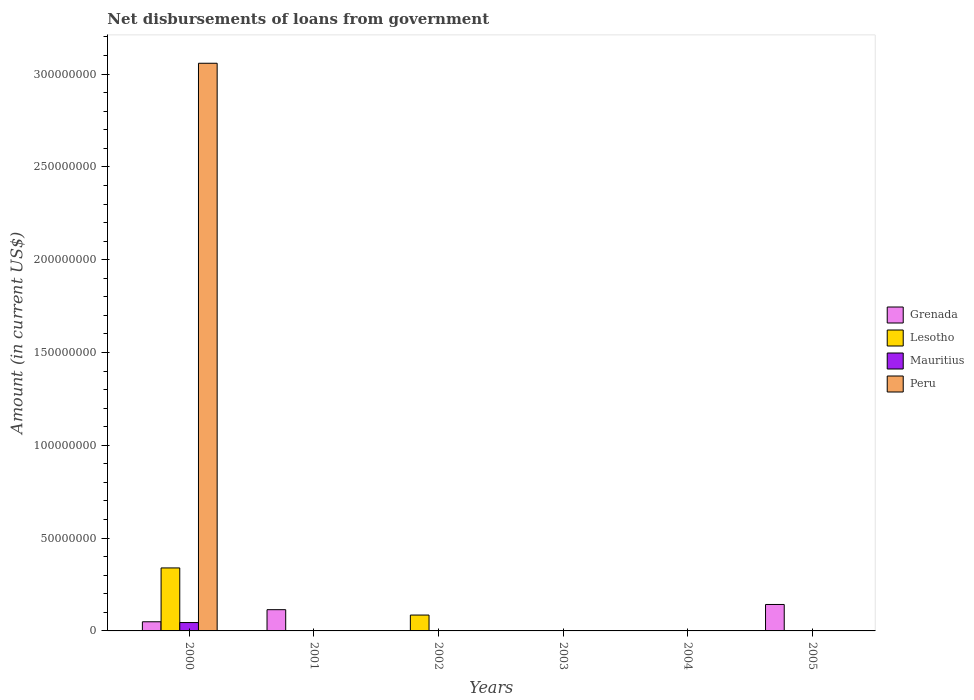How many different coloured bars are there?
Offer a very short reply. 4. How many bars are there on the 1st tick from the left?
Make the answer very short. 4. What is the label of the 4th group of bars from the left?
Ensure brevity in your answer.  2003. In how many cases, is the number of bars for a given year not equal to the number of legend labels?
Your answer should be very brief. 5. What is the amount of loan disbursed from government in Peru in 2000?
Ensure brevity in your answer.  3.06e+08. Across all years, what is the maximum amount of loan disbursed from government in Grenada?
Your answer should be compact. 1.42e+07. Across all years, what is the minimum amount of loan disbursed from government in Mauritius?
Make the answer very short. 0. In which year was the amount of loan disbursed from government in Lesotho maximum?
Ensure brevity in your answer.  2000. What is the total amount of loan disbursed from government in Lesotho in the graph?
Your answer should be very brief. 4.25e+07. What is the difference between the amount of loan disbursed from government in Grenada in 2000 and that in 2001?
Your answer should be very brief. -6.52e+06. What is the difference between the amount of loan disbursed from government in Peru in 2003 and the amount of loan disbursed from government in Grenada in 2005?
Your response must be concise. -1.42e+07. What is the average amount of loan disbursed from government in Peru per year?
Offer a terse response. 5.10e+07. In the year 2000, what is the difference between the amount of loan disbursed from government in Grenada and amount of loan disbursed from government in Mauritius?
Keep it short and to the point. 4.19e+05. What is the difference between the highest and the second highest amount of loan disbursed from government in Grenada?
Your answer should be compact. 2.80e+06. What is the difference between the highest and the lowest amount of loan disbursed from government in Lesotho?
Make the answer very short. 3.39e+07. How many bars are there?
Your response must be concise. 7. Are all the bars in the graph horizontal?
Keep it short and to the point. No. How many years are there in the graph?
Your answer should be compact. 6. What is the difference between two consecutive major ticks on the Y-axis?
Provide a short and direct response. 5.00e+07. How are the legend labels stacked?
Offer a very short reply. Vertical. What is the title of the graph?
Make the answer very short. Net disbursements of loans from government. Does "Aruba" appear as one of the legend labels in the graph?
Offer a very short reply. No. What is the label or title of the X-axis?
Your answer should be very brief. Years. What is the Amount (in current US$) of Grenada in 2000?
Your answer should be compact. 4.93e+06. What is the Amount (in current US$) in Lesotho in 2000?
Offer a terse response. 3.39e+07. What is the Amount (in current US$) of Mauritius in 2000?
Your answer should be very brief. 4.51e+06. What is the Amount (in current US$) of Peru in 2000?
Ensure brevity in your answer.  3.06e+08. What is the Amount (in current US$) of Grenada in 2001?
Your answer should be compact. 1.14e+07. What is the Amount (in current US$) in Peru in 2001?
Give a very brief answer. 0. What is the Amount (in current US$) of Grenada in 2002?
Provide a short and direct response. 0. What is the Amount (in current US$) in Lesotho in 2002?
Make the answer very short. 8.55e+06. What is the Amount (in current US$) of Peru in 2002?
Your response must be concise. 0. What is the Amount (in current US$) in Lesotho in 2003?
Provide a succinct answer. 0. What is the Amount (in current US$) in Peru in 2003?
Provide a short and direct response. 0. What is the Amount (in current US$) in Grenada in 2004?
Your response must be concise. 0. What is the Amount (in current US$) of Lesotho in 2004?
Offer a terse response. 0. What is the Amount (in current US$) of Mauritius in 2004?
Provide a succinct answer. 0. What is the Amount (in current US$) of Peru in 2004?
Offer a terse response. 0. What is the Amount (in current US$) of Grenada in 2005?
Your response must be concise. 1.42e+07. What is the Amount (in current US$) of Lesotho in 2005?
Offer a very short reply. 0. What is the Amount (in current US$) of Peru in 2005?
Your answer should be compact. 0. Across all years, what is the maximum Amount (in current US$) in Grenada?
Ensure brevity in your answer.  1.42e+07. Across all years, what is the maximum Amount (in current US$) in Lesotho?
Your response must be concise. 3.39e+07. Across all years, what is the maximum Amount (in current US$) in Mauritius?
Provide a succinct answer. 4.51e+06. Across all years, what is the maximum Amount (in current US$) in Peru?
Your response must be concise. 3.06e+08. Across all years, what is the minimum Amount (in current US$) of Lesotho?
Offer a terse response. 0. Across all years, what is the minimum Amount (in current US$) in Mauritius?
Ensure brevity in your answer.  0. Across all years, what is the minimum Amount (in current US$) of Peru?
Offer a terse response. 0. What is the total Amount (in current US$) of Grenada in the graph?
Offer a terse response. 3.06e+07. What is the total Amount (in current US$) of Lesotho in the graph?
Provide a succinct answer. 4.25e+07. What is the total Amount (in current US$) in Mauritius in the graph?
Keep it short and to the point. 4.51e+06. What is the total Amount (in current US$) in Peru in the graph?
Keep it short and to the point. 3.06e+08. What is the difference between the Amount (in current US$) of Grenada in 2000 and that in 2001?
Keep it short and to the point. -6.52e+06. What is the difference between the Amount (in current US$) of Lesotho in 2000 and that in 2002?
Provide a short and direct response. 2.54e+07. What is the difference between the Amount (in current US$) in Grenada in 2000 and that in 2005?
Provide a succinct answer. -9.32e+06. What is the difference between the Amount (in current US$) of Grenada in 2001 and that in 2005?
Your response must be concise. -2.80e+06. What is the difference between the Amount (in current US$) of Grenada in 2000 and the Amount (in current US$) of Lesotho in 2002?
Your answer should be very brief. -3.62e+06. What is the difference between the Amount (in current US$) in Grenada in 2001 and the Amount (in current US$) in Lesotho in 2002?
Keep it short and to the point. 2.90e+06. What is the average Amount (in current US$) of Grenada per year?
Provide a short and direct response. 5.10e+06. What is the average Amount (in current US$) of Lesotho per year?
Offer a terse response. 7.08e+06. What is the average Amount (in current US$) of Mauritius per year?
Your response must be concise. 7.52e+05. What is the average Amount (in current US$) of Peru per year?
Give a very brief answer. 5.10e+07. In the year 2000, what is the difference between the Amount (in current US$) in Grenada and Amount (in current US$) in Lesotho?
Provide a succinct answer. -2.90e+07. In the year 2000, what is the difference between the Amount (in current US$) of Grenada and Amount (in current US$) of Mauritius?
Keep it short and to the point. 4.19e+05. In the year 2000, what is the difference between the Amount (in current US$) of Grenada and Amount (in current US$) of Peru?
Your answer should be compact. -3.01e+08. In the year 2000, what is the difference between the Amount (in current US$) of Lesotho and Amount (in current US$) of Mauritius?
Give a very brief answer. 2.94e+07. In the year 2000, what is the difference between the Amount (in current US$) in Lesotho and Amount (in current US$) in Peru?
Provide a succinct answer. -2.72e+08. In the year 2000, what is the difference between the Amount (in current US$) of Mauritius and Amount (in current US$) of Peru?
Your response must be concise. -3.01e+08. What is the ratio of the Amount (in current US$) of Grenada in 2000 to that in 2001?
Provide a short and direct response. 0.43. What is the ratio of the Amount (in current US$) in Lesotho in 2000 to that in 2002?
Provide a succinct answer. 3.97. What is the ratio of the Amount (in current US$) in Grenada in 2000 to that in 2005?
Your answer should be compact. 0.35. What is the ratio of the Amount (in current US$) of Grenada in 2001 to that in 2005?
Your answer should be compact. 0.8. What is the difference between the highest and the second highest Amount (in current US$) in Grenada?
Provide a succinct answer. 2.80e+06. What is the difference between the highest and the lowest Amount (in current US$) in Grenada?
Ensure brevity in your answer.  1.42e+07. What is the difference between the highest and the lowest Amount (in current US$) of Lesotho?
Provide a short and direct response. 3.39e+07. What is the difference between the highest and the lowest Amount (in current US$) of Mauritius?
Your answer should be compact. 4.51e+06. What is the difference between the highest and the lowest Amount (in current US$) of Peru?
Keep it short and to the point. 3.06e+08. 